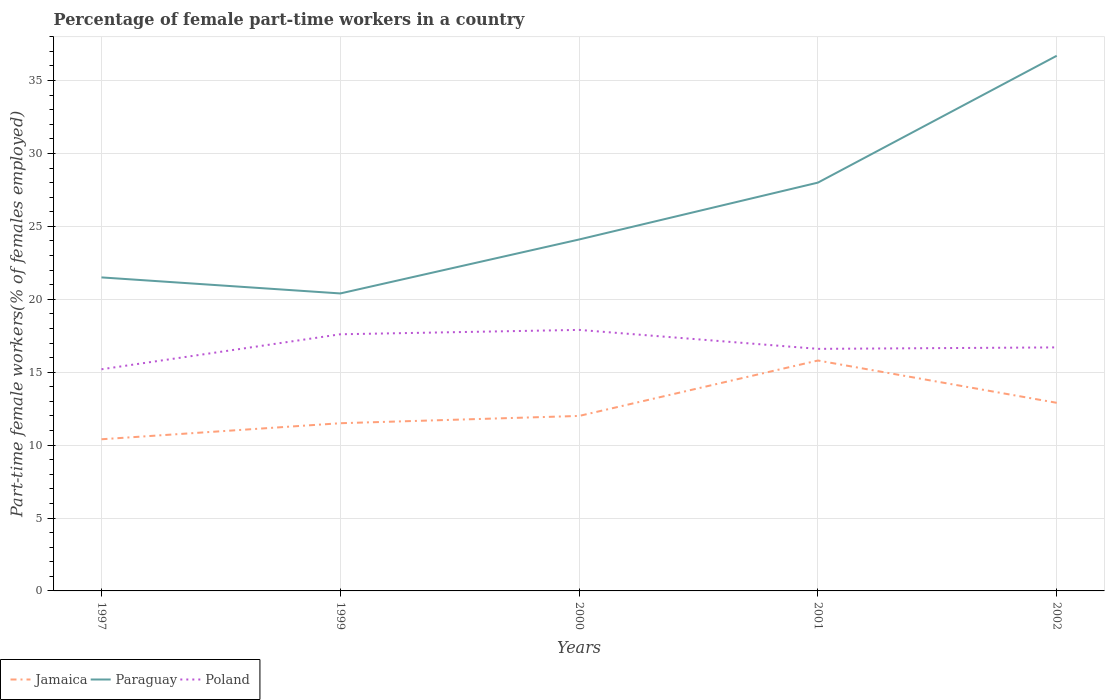How many different coloured lines are there?
Your answer should be very brief. 3. Does the line corresponding to Jamaica intersect with the line corresponding to Poland?
Keep it short and to the point. No. Is the number of lines equal to the number of legend labels?
Offer a very short reply. Yes. Across all years, what is the maximum percentage of female part-time workers in Paraguay?
Give a very brief answer. 20.4. In which year was the percentage of female part-time workers in Poland maximum?
Give a very brief answer. 1997. What is the difference between the highest and the second highest percentage of female part-time workers in Paraguay?
Offer a very short reply. 16.3. What is the difference between the highest and the lowest percentage of female part-time workers in Jamaica?
Provide a short and direct response. 2. How many lines are there?
Make the answer very short. 3. How many years are there in the graph?
Provide a succinct answer. 5. What is the difference between two consecutive major ticks on the Y-axis?
Your answer should be compact. 5. Are the values on the major ticks of Y-axis written in scientific E-notation?
Give a very brief answer. No. Does the graph contain grids?
Provide a short and direct response. Yes. What is the title of the graph?
Make the answer very short. Percentage of female part-time workers in a country. Does "Austria" appear as one of the legend labels in the graph?
Keep it short and to the point. No. What is the label or title of the Y-axis?
Your response must be concise. Part-time female workers(% of females employed). What is the Part-time female workers(% of females employed) of Jamaica in 1997?
Your answer should be very brief. 10.4. What is the Part-time female workers(% of females employed) of Poland in 1997?
Provide a short and direct response. 15.2. What is the Part-time female workers(% of females employed) in Paraguay in 1999?
Provide a succinct answer. 20.4. What is the Part-time female workers(% of females employed) in Poland in 1999?
Ensure brevity in your answer.  17.6. What is the Part-time female workers(% of females employed) in Paraguay in 2000?
Provide a succinct answer. 24.1. What is the Part-time female workers(% of females employed) in Poland in 2000?
Your answer should be very brief. 17.9. What is the Part-time female workers(% of females employed) of Jamaica in 2001?
Offer a very short reply. 15.8. What is the Part-time female workers(% of females employed) of Paraguay in 2001?
Provide a succinct answer. 28. What is the Part-time female workers(% of females employed) of Poland in 2001?
Keep it short and to the point. 16.6. What is the Part-time female workers(% of females employed) in Jamaica in 2002?
Ensure brevity in your answer.  12.9. What is the Part-time female workers(% of females employed) of Paraguay in 2002?
Provide a succinct answer. 36.7. What is the Part-time female workers(% of females employed) of Poland in 2002?
Provide a short and direct response. 16.7. Across all years, what is the maximum Part-time female workers(% of females employed) in Jamaica?
Make the answer very short. 15.8. Across all years, what is the maximum Part-time female workers(% of females employed) of Paraguay?
Ensure brevity in your answer.  36.7. Across all years, what is the maximum Part-time female workers(% of females employed) of Poland?
Provide a short and direct response. 17.9. Across all years, what is the minimum Part-time female workers(% of females employed) in Jamaica?
Offer a very short reply. 10.4. Across all years, what is the minimum Part-time female workers(% of females employed) in Paraguay?
Make the answer very short. 20.4. Across all years, what is the minimum Part-time female workers(% of females employed) of Poland?
Keep it short and to the point. 15.2. What is the total Part-time female workers(% of females employed) of Jamaica in the graph?
Keep it short and to the point. 62.6. What is the total Part-time female workers(% of females employed) in Paraguay in the graph?
Offer a terse response. 130.7. What is the total Part-time female workers(% of females employed) in Poland in the graph?
Provide a succinct answer. 84. What is the difference between the Part-time female workers(% of females employed) of Paraguay in 1997 and that in 1999?
Make the answer very short. 1.1. What is the difference between the Part-time female workers(% of females employed) in Jamaica in 1997 and that in 2000?
Offer a very short reply. -1.6. What is the difference between the Part-time female workers(% of females employed) of Paraguay in 1997 and that in 2000?
Your response must be concise. -2.6. What is the difference between the Part-time female workers(% of females employed) in Jamaica in 1997 and that in 2001?
Offer a terse response. -5.4. What is the difference between the Part-time female workers(% of females employed) of Paraguay in 1997 and that in 2001?
Provide a succinct answer. -6.5. What is the difference between the Part-time female workers(% of females employed) of Jamaica in 1997 and that in 2002?
Make the answer very short. -2.5. What is the difference between the Part-time female workers(% of females employed) of Paraguay in 1997 and that in 2002?
Ensure brevity in your answer.  -15.2. What is the difference between the Part-time female workers(% of females employed) of Poland in 1997 and that in 2002?
Your answer should be very brief. -1.5. What is the difference between the Part-time female workers(% of females employed) in Paraguay in 1999 and that in 2000?
Ensure brevity in your answer.  -3.7. What is the difference between the Part-time female workers(% of females employed) in Jamaica in 1999 and that in 2002?
Give a very brief answer. -1.4. What is the difference between the Part-time female workers(% of females employed) of Paraguay in 1999 and that in 2002?
Make the answer very short. -16.3. What is the difference between the Part-time female workers(% of females employed) in Poland in 1999 and that in 2002?
Make the answer very short. 0.9. What is the difference between the Part-time female workers(% of females employed) in Paraguay in 2000 and that in 2002?
Offer a very short reply. -12.6. What is the difference between the Part-time female workers(% of females employed) in Paraguay in 2001 and that in 2002?
Keep it short and to the point. -8.7. What is the difference between the Part-time female workers(% of females employed) in Poland in 2001 and that in 2002?
Your answer should be compact. -0.1. What is the difference between the Part-time female workers(% of females employed) of Jamaica in 1997 and the Part-time female workers(% of females employed) of Poland in 1999?
Give a very brief answer. -7.2. What is the difference between the Part-time female workers(% of females employed) of Jamaica in 1997 and the Part-time female workers(% of females employed) of Paraguay in 2000?
Keep it short and to the point. -13.7. What is the difference between the Part-time female workers(% of females employed) of Jamaica in 1997 and the Part-time female workers(% of females employed) of Paraguay in 2001?
Provide a succinct answer. -17.6. What is the difference between the Part-time female workers(% of females employed) of Jamaica in 1997 and the Part-time female workers(% of females employed) of Poland in 2001?
Your answer should be compact. -6.2. What is the difference between the Part-time female workers(% of females employed) in Jamaica in 1997 and the Part-time female workers(% of females employed) in Paraguay in 2002?
Your response must be concise. -26.3. What is the difference between the Part-time female workers(% of females employed) of Jamaica in 1997 and the Part-time female workers(% of females employed) of Poland in 2002?
Offer a terse response. -6.3. What is the difference between the Part-time female workers(% of females employed) of Paraguay in 1997 and the Part-time female workers(% of females employed) of Poland in 2002?
Make the answer very short. 4.8. What is the difference between the Part-time female workers(% of females employed) in Jamaica in 1999 and the Part-time female workers(% of females employed) in Paraguay in 2000?
Your answer should be very brief. -12.6. What is the difference between the Part-time female workers(% of females employed) of Jamaica in 1999 and the Part-time female workers(% of females employed) of Poland in 2000?
Make the answer very short. -6.4. What is the difference between the Part-time female workers(% of females employed) in Jamaica in 1999 and the Part-time female workers(% of females employed) in Paraguay in 2001?
Offer a very short reply. -16.5. What is the difference between the Part-time female workers(% of females employed) of Jamaica in 1999 and the Part-time female workers(% of females employed) of Poland in 2001?
Give a very brief answer. -5.1. What is the difference between the Part-time female workers(% of females employed) in Jamaica in 1999 and the Part-time female workers(% of females employed) in Paraguay in 2002?
Provide a short and direct response. -25.2. What is the difference between the Part-time female workers(% of females employed) in Jamaica in 1999 and the Part-time female workers(% of females employed) in Poland in 2002?
Your response must be concise. -5.2. What is the difference between the Part-time female workers(% of females employed) in Paraguay in 1999 and the Part-time female workers(% of females employed) in Poland in 2002?
Give a very brief answer. 3.7. What is the difference between the Part-time female workers(% of females employed) in Jamaica in 2000 and the Part-time female workers(% of females employed) in Paraguay in 2002?
Offer a terse response. -24.7. What is the difference between the Part-time female workers(% of females employed) of Jamaica in 2000 and the Part-time female workers(% of females employed) of Poland in 2002?
Give a very brief answer. -4.7. What is the difference between the Part-time female workers(% of females employed) in Jamaica in 2001 and the Part-time female workers(% of females employed) in Paraguay in 2002?
Ensure brevity in your answer.  -20.9. What is the difference between the Part-time female workers(% of females employed) in Jamaica in 2001 and the Part-time female workers(% of females employed) in Poland in 2002?
Provide a short and direct response. -0.9. What is the difference between the Part-time female workers(% of females employed) of Paraguay in 2001 and the Part-time female workers(% of females employed) of Poland in 2002?
Ensure brevity in your answer.  11.3. What is the average Part-time female workers(% of females employed) of Jamaica per year?
Your response must be concise. 12.52. What is the average Part-time female workers(% of females employed) of Paraguay per year?
Your answer should be very brief. 26.14. What is the average Part-time female workers(% of females employed) of Poland per year?
Make the answer very short. 16.8. In the year 1997, what is the difference between the Part-time female workers(% of females employed) in Jamaica and Part-time female workers(% of females employed) in Poland?
Make the answer very short. -4.8. In the year 1999, what is the difference between the Part-time female workers(% of females employed) in Jamaica and Part-time female workers(% of females employed) in Paraguay?
Provide a short and direct response. -8.9. In the year 1999, what is the difference between the Part-time female workers(% of females employed) in Paraguay and Part-time female workers(% of females employed) in Poland?
Your answer should be compact. 2.8. In the year 2000, what is the difference between the Part-time female workers(% of females employed) in Jamaica and Part-time female workers(% of females employed) in Paraguay?
Your answer should be compact. -12.1. In the year 2000, what is the difference between the Part-time female workers(% of females employed) in Jamaica and Part-time female workers(% of females employed) in Poland?
Ensure brevity in your answer.  -5.9. In the year 2001, what is the difference between the Part-time female workers(% of females employed) of Jamaica and Part-time female workers(% of females employed) of Paraguay?
Keep it short and to the point. -12.2. In the year 2002, what is the difference between the Part-time female workers(% of females employed) of Jamaica and Part-time female workers(% of females employed) of Paraguay?
Make the answer very short. -23.8. In the year 2002, what is the difference between the Part-time female workers(% of females employed) in Paraguay and Part-time female workers(% of females employed) in Poland?
Make the answer very short. 20. What is the ratio of the Part-time female workers(% of females employed) in Jamaica in 1997 to that in 1999?
Your answer should be compact. 0.9. What is the ratio of the Part-time female workers(% of females employed) in Paraguay in 1997 to that in 1999?
Make the answer very short. 1.05. What is the ratio of the Part-time female workers(% of females employed) in Poland in 1997 to that in 1999?
Give a very brief answer. 0.86. What is the ratio of the Part-time female workers(% of females employed) in Jamaica in 1997 to that in 2000?
Offer a terse response. 0.87. What is the ratio of the Part-time female workers(% of females employed) of Paraguay in 1997 to that in 2000?
Keep it short and to the point. 0.89. What is the ratio of the Part-time female workers(% of females employed) of Poland in 1997 to that in 2000?
Offer a very short reply. 0.85. What is the ratio of the Part-time female workers(% of females employed) of Jamaica in 1997 to that in 2001?
Ensure brevity in your answer.  0.66. What is the ratio of the Part-time female workers(% of females employed) of Paraguay in 1997 to that in 2001?
Keep it short and to the point. 0.77. What is the ratio of the Part-time female workers(% of females employed) in Poland in 1997 to that in 2001?
Your answer should be compact. 0.92. What is the ratio of the Part-time female workers(% of females employed) of Jamaica in 1997 to that in 2002?
Offer a terse response. 0.81. What is the ratio of the Part-time female workers(% of females employed) of Paraguay in 1997 to that in 2002?
Offer a terse response. 0.59. What is the ratio of the Part-time female workers(% of females employed) of Poland in 1997 to that in 2002?
Your response must be concise. 0.91. What is the ratio of the Part-time female workers(% of females employed) of Paraguay in 1999 to that in 2000?
Offer a terse response. 0.85. What is the ratio of the Part-time female workers(% of females employed) in Poland in 1999 to that in 2000?
Your answer should be compact. 0.98. What is the ratio of the Part-time female workers(% of females employed) in Jamaica in 1999 to that in 2001?
Give a very brief answer. 0.73. What is the ratio of the Part-time female workers(% of females employed) of Paraguay in 1999 to that in 2001?
Offer a very short reply. 0.73. What is the ratio of the Part-time female workers(% of females employed) in Poland in 1999 to that in 2001?
Make the answer very short. 1.06. What is the ratio of the Part-time female workers(% of females employed) of Jamaica in 1999 to that in 2002?
Provide a short and direct response. 0.89. What is the ratio of the Part-time female workers(% of females employed) in Paraguay in 1999 to that in 2002?
Your response must be concise. 0.56. What is the ratio of the Part-time female workers(% of females employed) of Poland in 1999 to that in 2002?
Make the answer very short. 1.05. What is the ratio of the Part-time female workers(% of females employed) in Jamaica in 2000 to that in 2001?
Your answer should be compact. 0.76. What is the ratio of the Part-time female workers(% of females employed) of Paraguay in 2000 to that in 2001?
Provide a succinct answer. 0.86. What is the ratio of the Part-time female workers(% of females employed) of Poland in 2000 to that in 2001?
Offer a terse response. 1.08. What is the ratio of the Part-time female workers(% of females employed) in Jamaica in 2000 to that in 2002?
Provide a succinct answer. 0.93. What is the ratio of the Part-time female workers(% of females employed) in Paraguay in 2000 to that in 2002?
Ensure brevity in your answer.  0.66. What is the ratio of the Part-time female workers(% of females employed) of Poland in 2000 to that in 2002?
Keep it short and to the point. 1.07. What is the ratio of the Part-time female workers(% of females employed) of Jamaica in 2001 to that in 2002?
Provide a short and direct response. 1.22. What is the ratio of the Part-time female workers(% of females employed) of Paraguay in 2001 to that in 2002?
Make the answer very short. 0.76. What is the difference between the highest and the second highest Part-time female workers(% of females employed) of Jamaica?
Offer a terse response. 2.9. What is the difference between the highest and the second highest Part-time female workers(% of females employed) in Paraguay?
Offer a very short reply. 8.7. What is the difference between the highest and the lowest Part-time female workers(% of females employed) in Paraguay?
Ensure brevity in your answer.  16.3. 